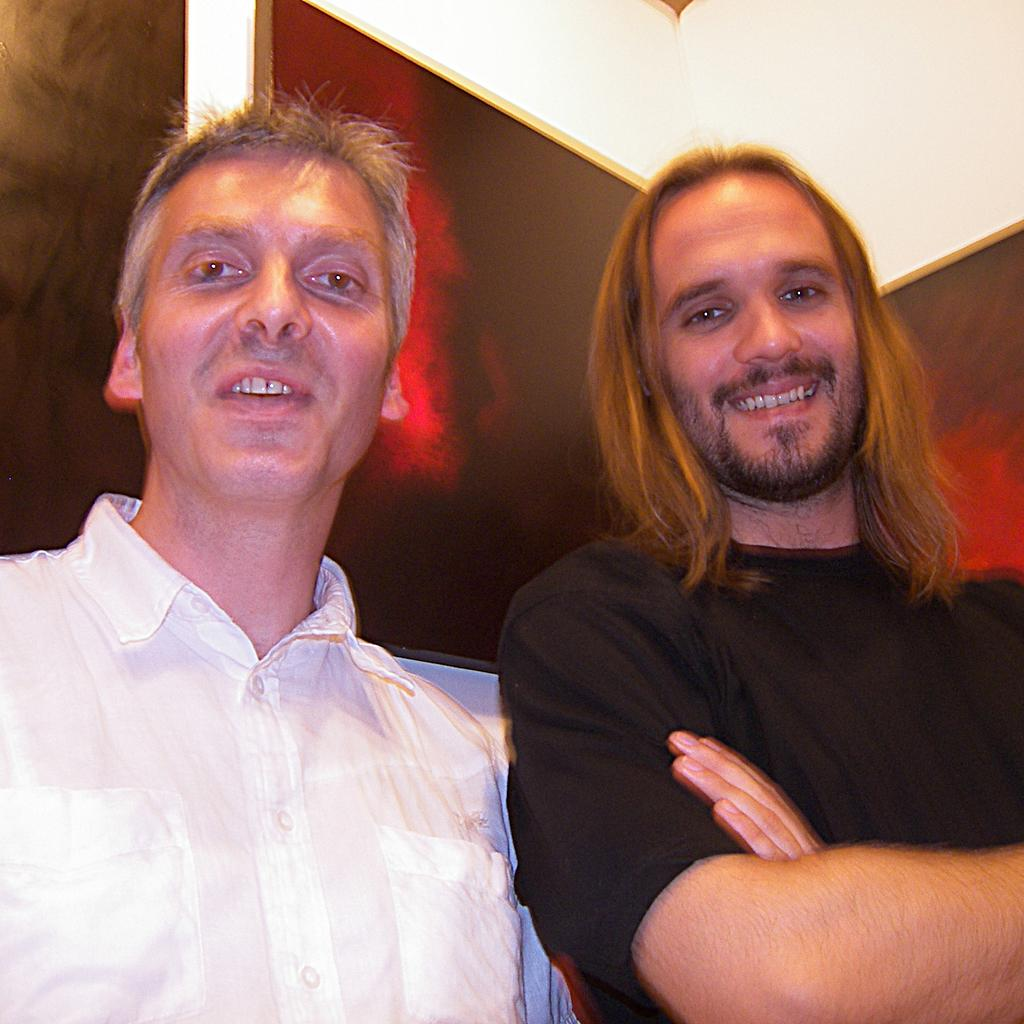What is the position of the man wearing a white color shirt in the image? The man wearing a white color shirt is on the left side of the image. What is the man on the left side wearing? The man on the left side is wearing a white color shirt. What is the position of the man wearing a black color t-shirt in the image? The man wearing a black color t-shirt is on the right side of the image. What is the man on the right side holding? The man on the right side is holding his hands. What is the man on the right side wearing? The man on the right side is wearing a black color t-shirt. What is the expression on the face of the man on the right side? The man on the right side is smiling. How many snails can be seen crawling on the man wearing a white color shirt in the image? There are no snails visible on the man wearing a white color shirt in the image. What is the mass of the man on the right side in the image? The mass of the man on the right side cannot be determined from the image alone. 